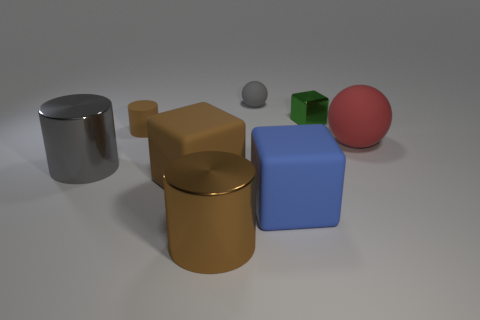Add 1 large brown rubber objects. How many objects exist? 9 Subtract all cylinders. How many objects are left? 5 Add 5 big red objects. How many big red objects are left? 6 Add 8 small spheres. How many small spheres exist? 9 Subtract 0 blue cylinders. How many objects are left? 8 Subtract all brown matte cubes. Subtract all big gray shiny objects. How many objects are left? 6 